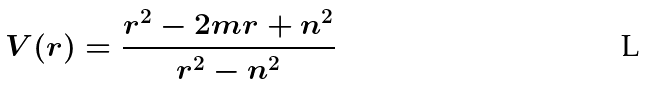Convert formula to latex. <formula><loc_0><loc_0><loc_500><loc_500>V ( r ) = \frac { r ^ { 2 } - 2 m r + n ^ { 2 } } { r ^ { 2 } - n ^ { 2 } }</formula> 